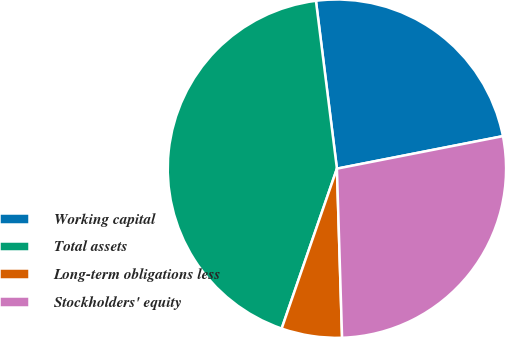Convert chart to OTSL. <chart><loc_0><loc_0><loc_500><loc_500><pie_chart><fcel>Working capital<fcel>Total assets<fcel>Long-term obligations less<fcel>Stockholders' equity<nl><fcel>23.9%<fcel>42.72%<fcel>5.78%<fcel>27.59%<nl></chart> 